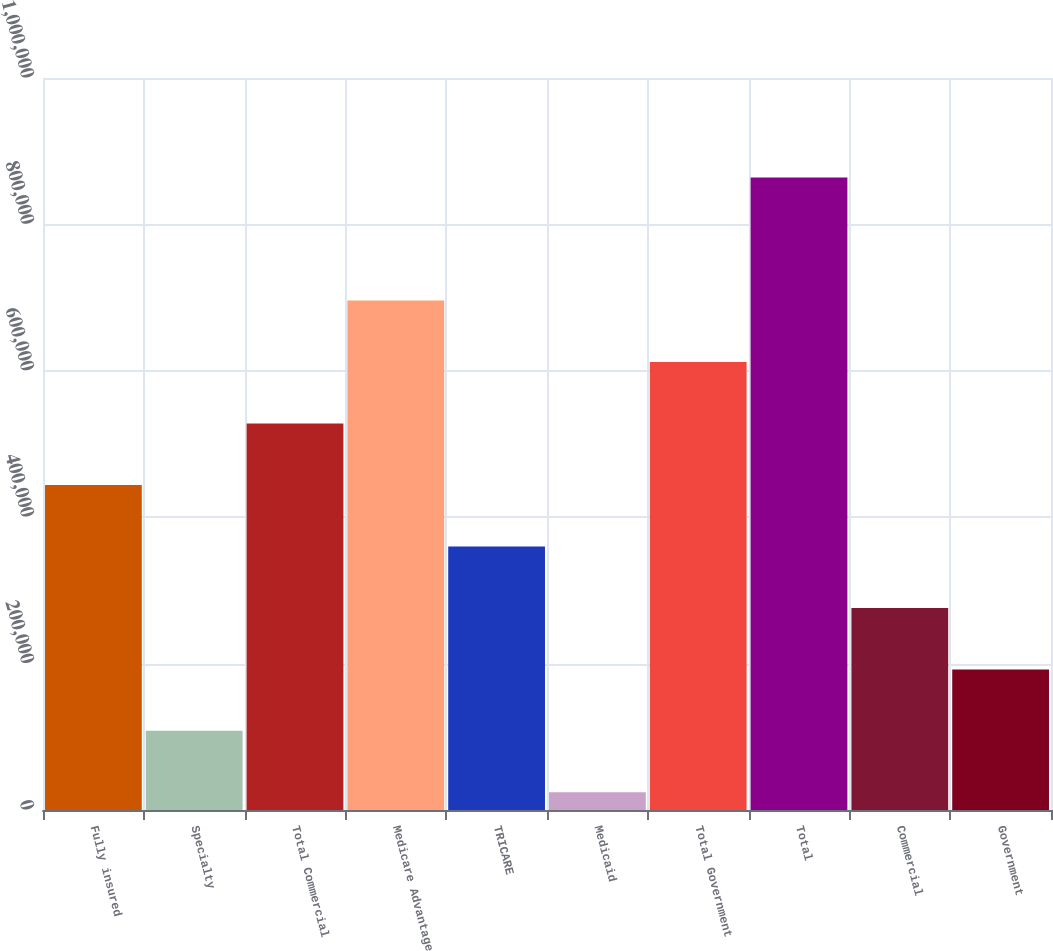<chart> <loc_0><loc_0><loc_500><loc_500><bar_chart><fcel>Fully insured<fcel>Specialty<fcel>Total Commercial<fcel>Medicare Advantage<fcel>TRICARE<fcel>Medicaid<fcel>Total Government<fcel>Total<fcel>Commercial<fcel>Government<nl><fcel>444121<fcel>108099<fcel>528127<fcel>696138<fcel>360115<fcel>24093<fcel>612132<fcel>864149<fcel>276110<fcel>192104<nl></chart> 